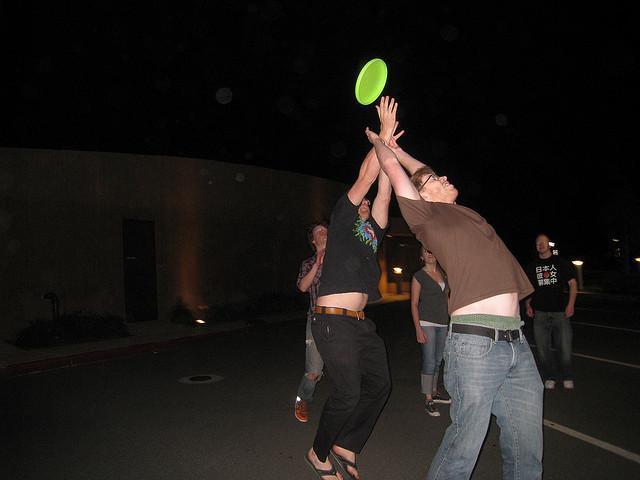WHat language is on the black shirt?
Pick the right solution, then justify: 'Answer: answer
Rationale: rationale.'
Options: Chinese, english, french, italian. Answer: chinese.
Rationale: The language is chinese. 